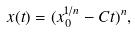Convert formula to latex. <formula><loc_0><loc_0><loc_500><loc_500>x ( t ) = ( x _ { 0 } ^ { 1 / n } - C t ) ^ { n } ,</formula> 